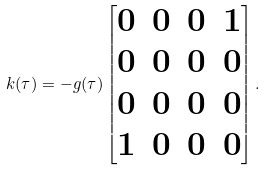<formula> <loc_0><loc_0><loc_500><loc_500>k ( \tau ) = - g ( \tau ) \begin{bmatrix} 0 & 0 & 0 & 1 \\ 0 & 0 & 0 & 0 \\ 0 & 0 & 0 & 0 \\ 1 & 0 & 0 & 0 \end{bmatrix} .</formula> 